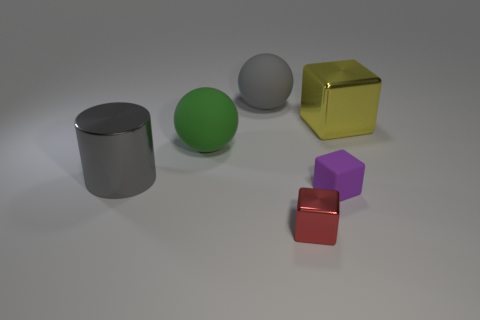Subtract all metal cubes. How many cubes are left? 1 Add 3 small purple metallic blocks. How many objects exist? 9 Subtract all yellow blocks. How many blocks are left? 2 Subtract 2 blocks. How many blocks are left? 1 Subtract all cylinders. How many objects are left? 5 Subtract 0 red cylinders. How many objects are left? 6 Subtract all red blocks. Subtract all purple balls. How many blocks are left? 2 Subtract all small blue metal cylinders. Subtract all metallic cylinders. How many objects are left? 5 Add 4 large yellow things. How many large yellow things are left? 5 Add 4 yellow rubber objects. How many yellow rubber objects exist? 4 